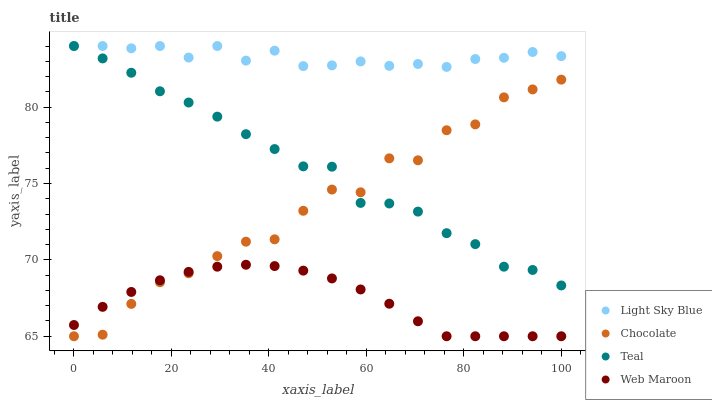Does Web Maroon have the minimum area under the curve?
Answer yes or no. Yes. Does Light Sky Blue have the maximum area under the curve?
Answer yes or no. Yes. Does Teal have the minimum area under the curve?
Answer yes or no. No. Does Teal have the maximum area under the curve?
Answer yes or no. No. Is Web Maroon the smoothest?
Answer yes or no. Yes. Is Chocolate the roughest?
Answer yes or no. Yes. Is Teal the smoothest?
Answer yes or no. No. Is Teal the roughest?
Answer yes or no. No. Does Web Maroon have the lowest value?
Answer yes or no. Yes. Does Teal have the lowest value?
Answer yes or no. No. Does Teal have the highest value?
Answer yes or no. Yes. Does Web Maroon have the highest value?
Answer yes or no. No. Is Chocolate less than Light Sky Blue?
Answer yes or no. Yes. Is Light Sky Blue greater than Web Maroon?
Answer yes or no. Yes. Does Teal intersect Light Sky Blue?
Answer yes or no. Yes. Is Teal less than Light Sky Blue?
Answer yes or no. No. Is Teal greater than Light Sky Blue?
Answer yes or no. No. Does Chocolate intersect Light Sky Blue?
Answer yes or no. No. 